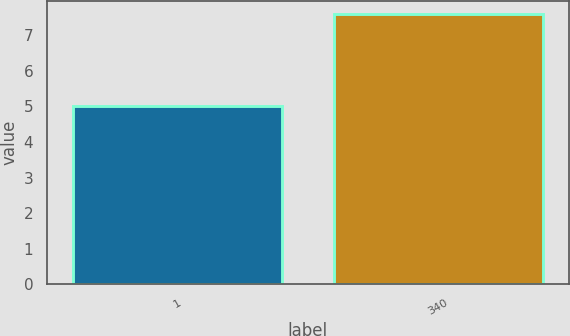Convert chart to OTSL. <chart><loc_0><loc_0><loc_500><loc_500><bar_chart><fcel>1<fcel>340<nl><fcel>5<fcel>7.6<nl></chart> 